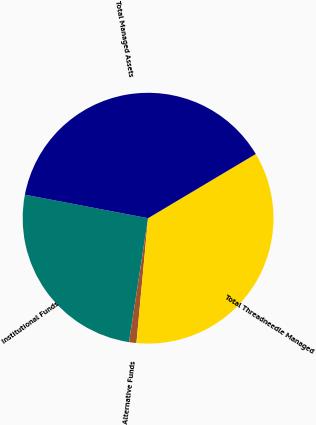Convert chart to OTSL. <chart><loc_0><loc_0><loc_500><loc_500><pie_chart><fcel>Institutional Funds<fcel>Alternative Funds<fcel>Total Threadneedle Managed<fcel>Total Managed Assets<nl><fcel>25.57%<fcel>0.95%<fcel>35.04%<fcel>38.45%<nl></chart> 